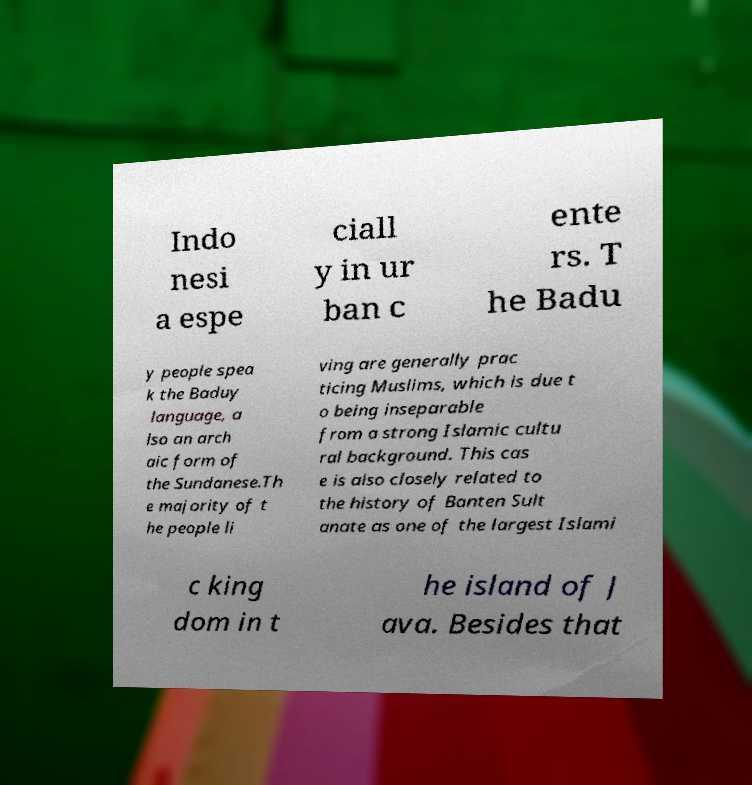What messages or text are displayed in this image? I need them in a readable, typed format. Indo nesi a espe ciall y in ur ban c ente rs. T he Badu y people spea k the Baduy language, a lso an arch aic form of the Sundanese.Th e majority of t he people li ving are generally prac ticing Muslims, which is due t o being inseparable from a strong Islamic cultu ral background. This cas e is also closely related to the history of Banten Sult anate as one of the largest Islami c king dom in t he island of J ava. Besides that 